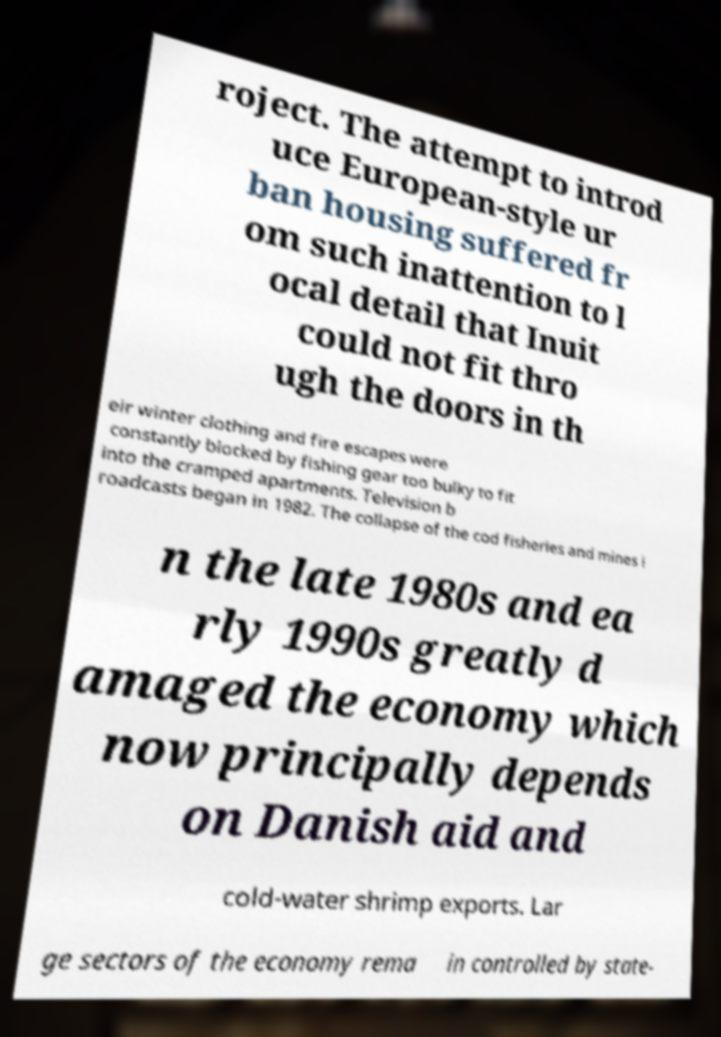Could you assist in decoding the text presented in this image and type it out clearly? roject. The attempt to introd uce European-style ur ban housing suffered fr om such inattention to l ocal detail that Inuit could not fit thro ugh the doors in th eir winter clothing and fire escapes were constantly blocked by fishing gear too bulky to fit into the cramped apartments. Television b roadcasts began in 1982. The collapse of the cod fisheries and mines i n the late 1980s and ea rly 1990s greatly d amaged the economy which now principally depends on Danish aid and cold-water shrimp exports. Lar ge sectors of the economy rema in controlled by state- 